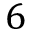Convert formula to latex. <formula><loc_0><loc_0><loc_500><loc_500>6</formula> 